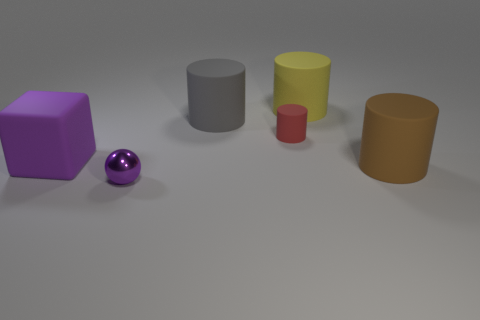Subtract all big gray cylinders. How many cylinders are left? 3 Subtract all brown cylinders. How many cylinders are left? 3 Subtract 3 cylinders. How many cylinders are left? 1 Subtract all gray blocks. How many yellow cylinders are left? 1 Subtract all large gray cylinders. Subtract all brown cylinders. How many objects are left? 4 Add 6 rubber cubes. How many rubber cubes are left? 7 Add 5 tiny matte cubes. How many tiny matte cubes exist? 5 Add 3 purple blocks. How many objects exist? 9 Subtract 1 gray cylinders. How many objects are left? 5 Subtract all balls. How many objects are left? 5 